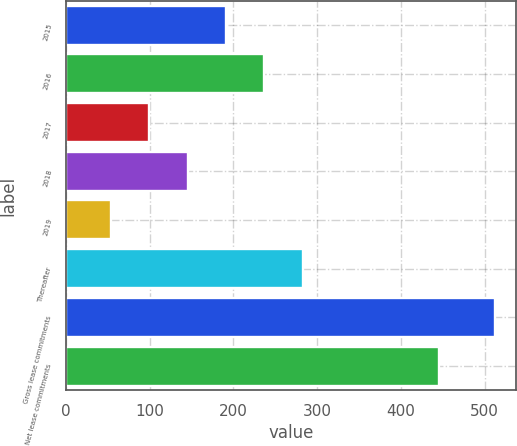<chart> <loc_0><loc_0><loc_500><loc_500><bar_chart><fcel>2015<fcel>2016<fcel>2017<fcel>2018<fcel>2019<fcel>Thereafter<fcel>Gross lease commitments<fcel>Net lease commitments<nl><fcel>191.23<fcel>237.04<fcel>99.61<fcel>145.42<fcel>53.8<fcel>282.85<fcel>511.9<fcel>445.9<nl></chart> 